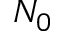<formula> <loc_0><loc_0><loc_500><loc_500>N _ { 0 }</formula> 